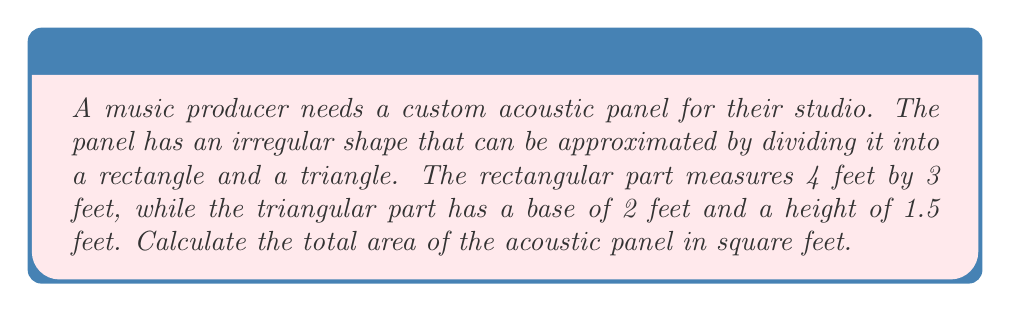Show me your answer to this math problem. To solve this problem, we'll calculate the areas of the rectangular and triangular parts separately, then add them together.

1. Area of the rectangular part:
   $$A_r = l \times w$$
   where $l$ is length and $w$ is width
   $$A_r = 4 \text{ ft} \times 3 \text{ ft} = 12 \text{ ft}^2$$

2. Area of the triangular part:
   $$A_t = \frac{1}{2} \times b \times h$$
   where $b$ is base and $h$ is height
   $$A_t = \frac{1}{2} \times 2 \text{ ft} \times 1.5 \text{ ft} = 1.5 \text{ ft}^2$$

3. Total area of the acoustic panel:
   $$A_{\text{total}} = A_r + A_t$$
   $$A_{\text{total}} = 12 \text{ ft}^2 + 1.5 \text{ ft}^2 = 13.5 \text{ ft}^2$$

[asy]
unitsize(30);
fill((0,0)--(4,0)--(4,3)--(2,3)--(0,1.5)--cycle,gray(0.8));
draw((0,0)--(4,0)--(4,3)--(2,3)--(0,1.5)--cycle);
draw((0,1.5)--(2,1.5));
label("4 ft", (2,-0.2), S);
label("3 ft", (4.2,1.5), E);
label("2 ft", (1,3.2), N);
label("1.5 ft", (-0.2,0.75), W);
[/asy]
Answer: 13.5 ft² 